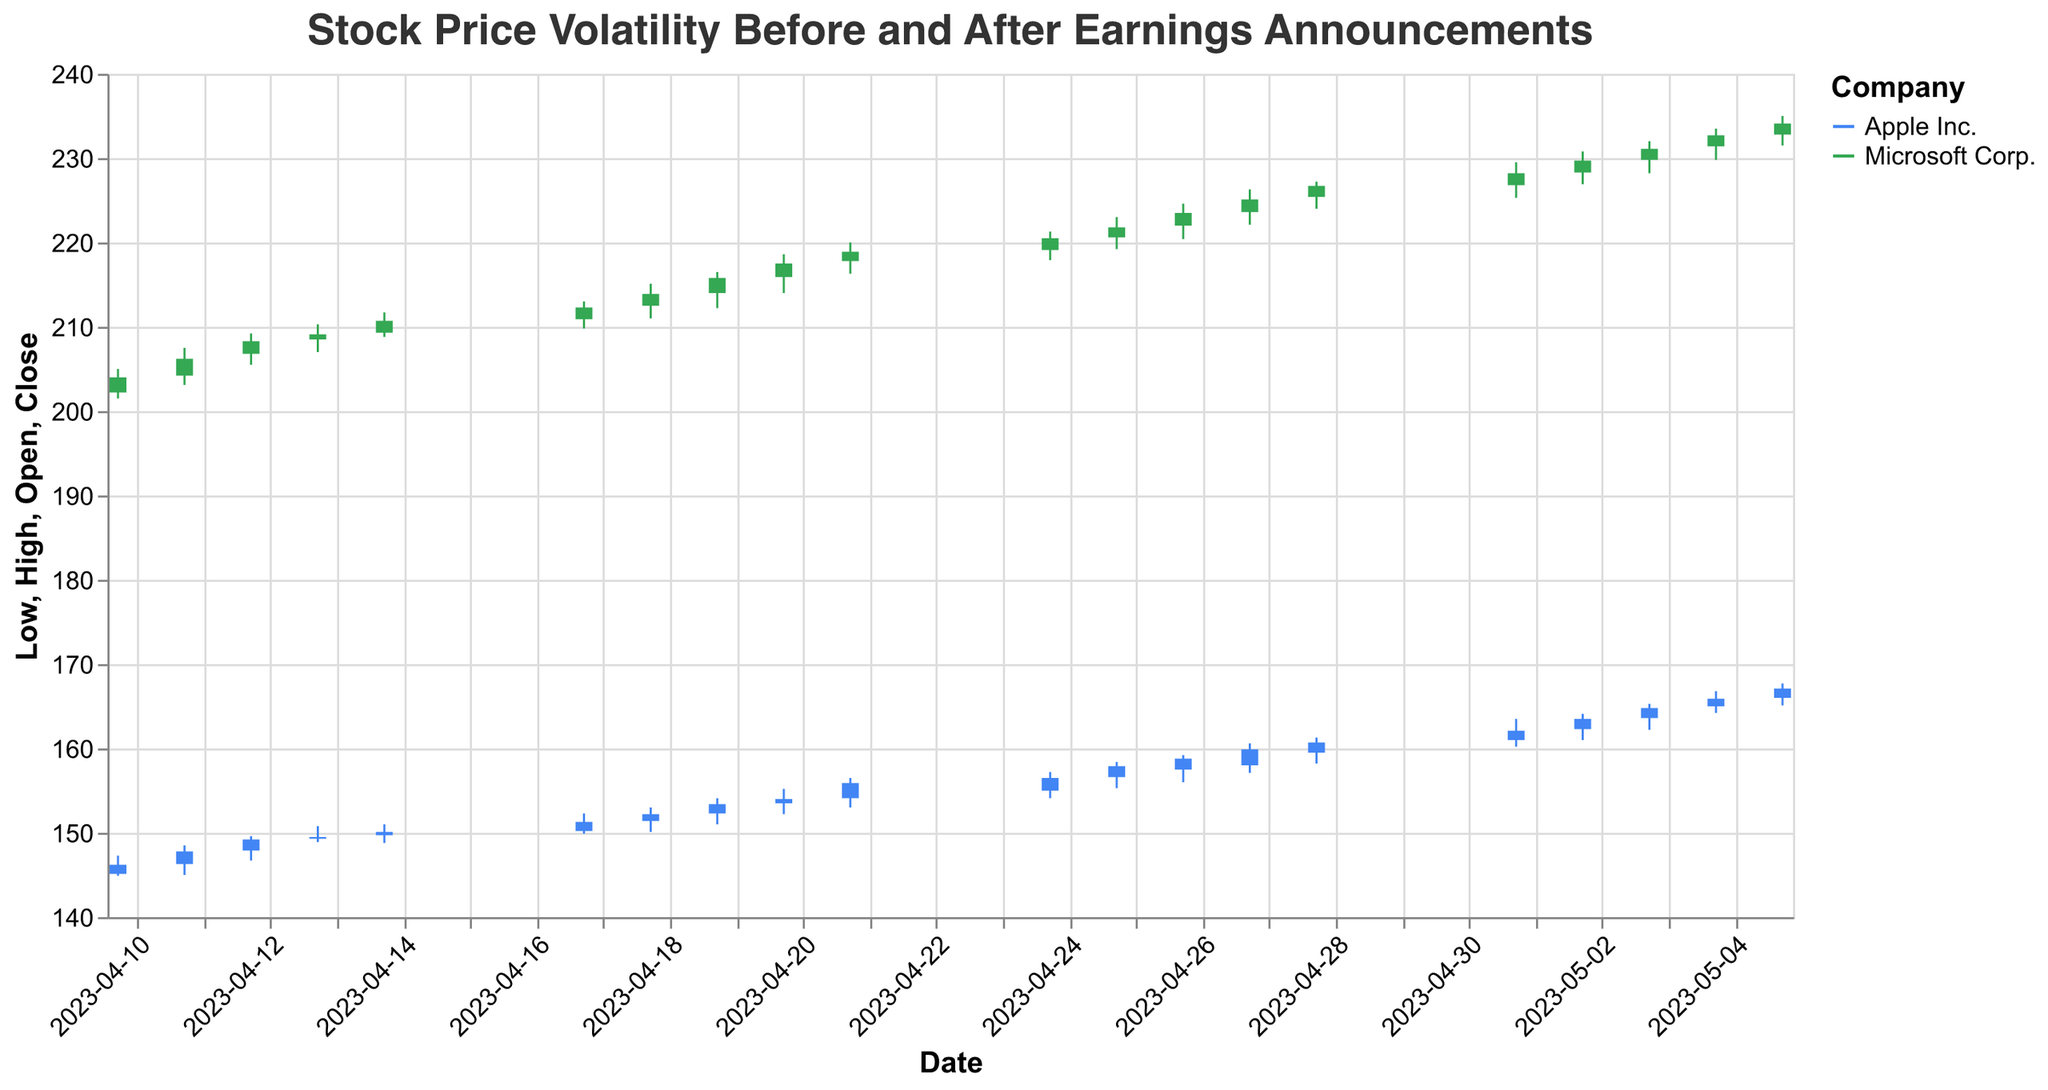What is the title of the plot? The title is usually positioned at the top of the plot and it helps explain the subject of the figure.
Answer: Stock Price Volatility Before and After Earnings Announcements What are the two companies represented in the plot? The color legend indicates the companies with distinct colors: one for each company.
Answer: Apple Inc. and Microsoft Corp On what date did Apple Inc. have the highest trading volume? Look for the highest volume value for Apple Inc. in the data.
Answer: 2023-05-05 How much did Microsoft's stock close at on 2023-04-14? Locate the candlestick for Microsoft Corp. on 2023-04-14 and check the closing price.
Answer: 210.70 How does the stock price of Apple Inc. on 2023-04-10 compare to its stock price on 2023-05-05? Compare the closing prices on the given dates for Apple Inc.
Answer: The stock increased from 146.20 to 167.10 What is the overall trend of Microsoft Corp.'s stock prices from 2023-04-10 to 2023-05-05? Evaluate if Microsoft’s stock prices generally go upward or downward over the specified time range.
Answer: Upward Between 2023-04-24 and 2023-04-28, what was the highest closing price for Apple Inc.? Look at the candlestick plot for Apple Inc. from 2023-04-24 to 2023-04-28 and identify the highest closing price.
Answer: 159.90 What was the range between the highest and the lowest stock price of Microsoft Corp. on 2023-05-05? Calculate the difference between the high and low values for Microsoft on 2023-05-05.
Answer: 3.50 During the period shown, did Apple Inc. or Microsoft Corp. experience greater overall price volatility? Price volatility can be assessed by looking at the range between highest and lowest prices over the period for both companies. Compare these ranges.
Answer: Microsoft Corp 